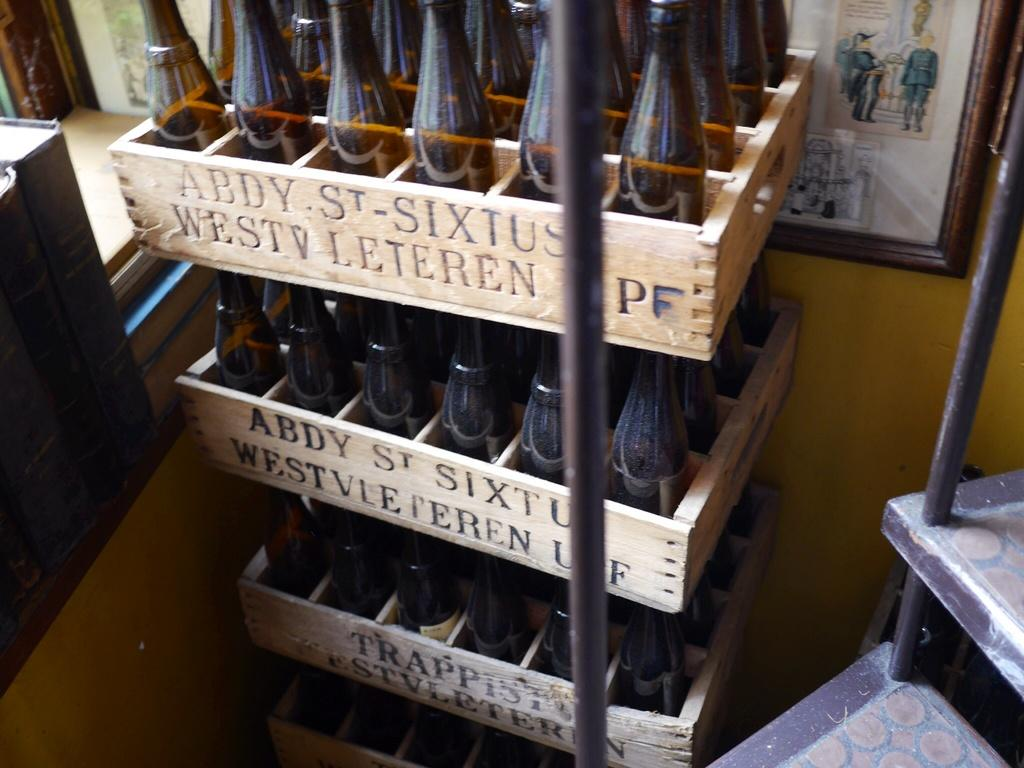<image>
Relay a brief, clear account of the picture shown. Bottles sit in a wooden box taht says Abdy St. Sixtus, Westv Leteren. 